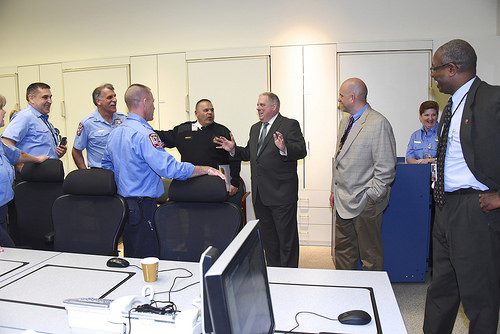<image>
Is there a man under the man? No. The man is not positioned under the man. The vertical relationship between these objects is different. 